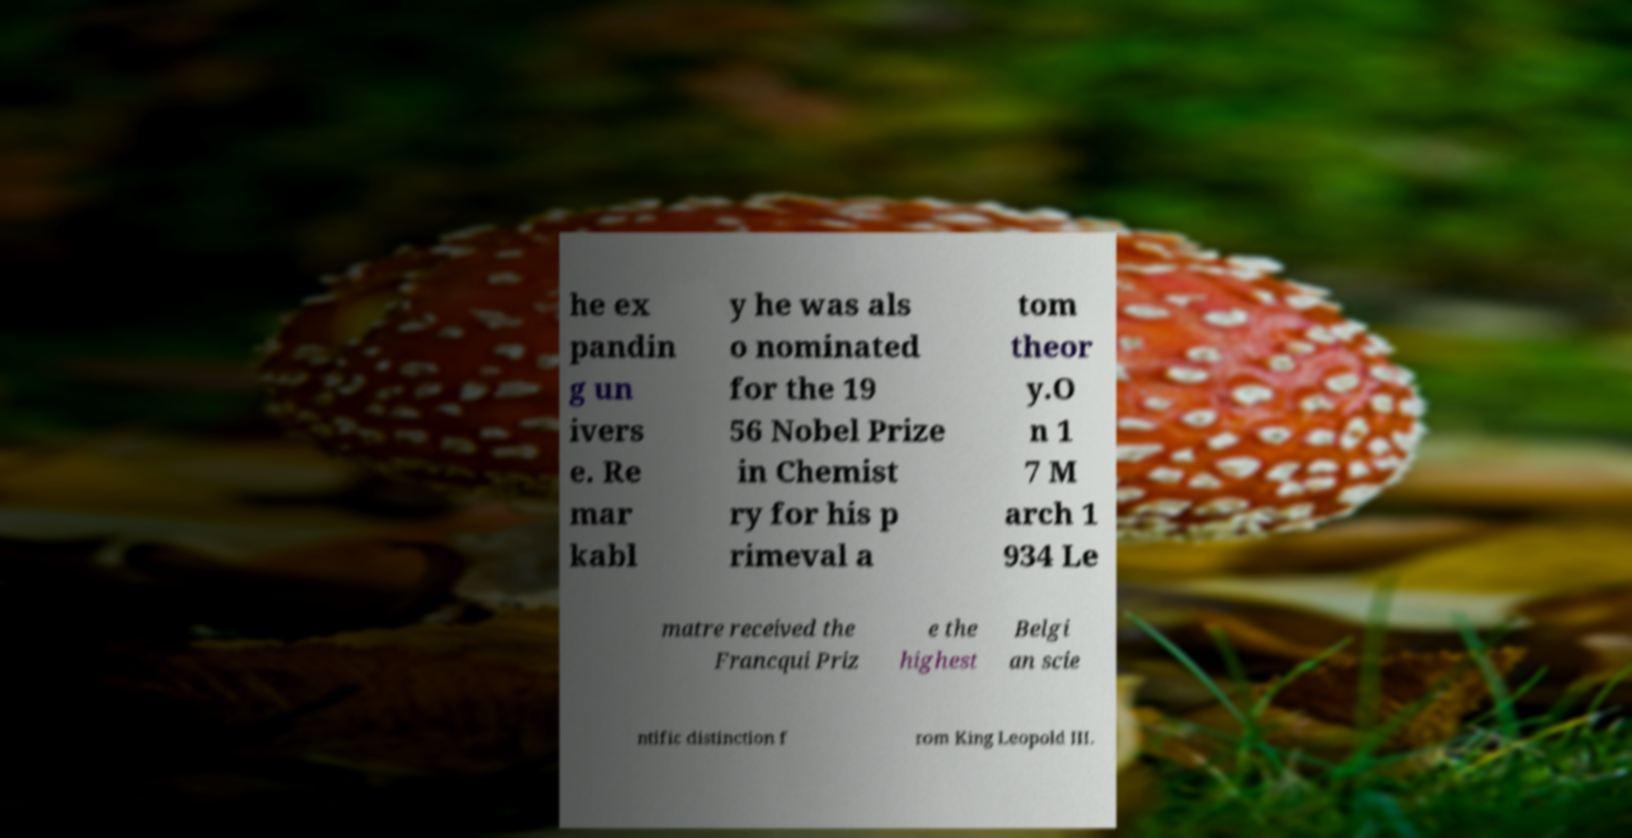Could you extract and type out the text from this image? he ex pandin g un ivers e. Re mar kabl y he was als o nominated for the 19 56 Nobel Prize in Chemist ry for his p rimeval a tom theor y.O n 1 7 M arch 1 934 Le matre received the Francqui Priz e the highest Belgi an scie ntific distinction f rom King Leopold III. 